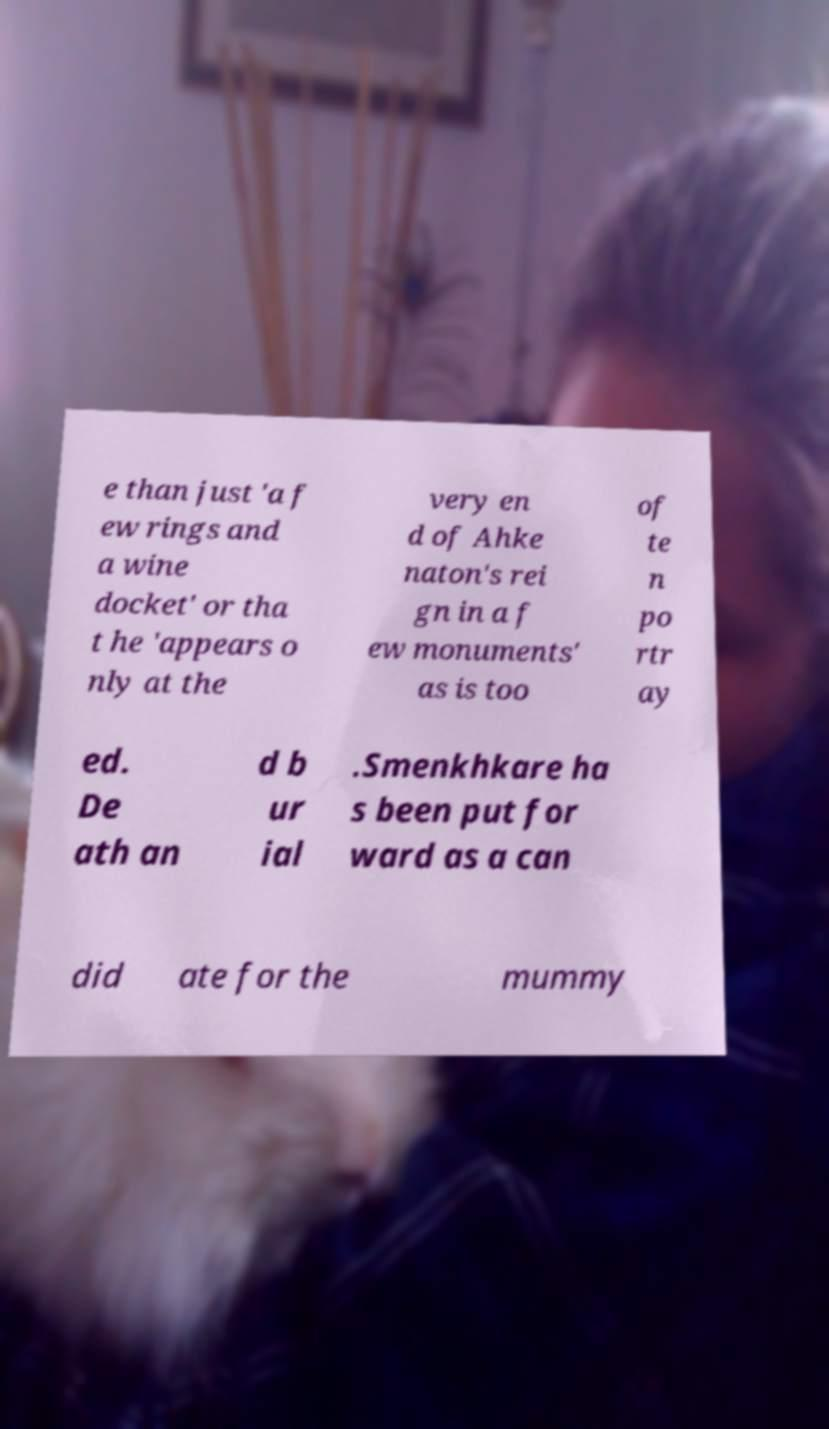For documentation purposes, I need the text within this image transcribed. Could you provide that? e than just 'a f ew rings and a wine docket' or tha t he 'appears o nly at the very en d of Ahke naton's rei gn in a f ew monuments' as is too of te n po rtr ay ed. De ath an d b ur ial .Smenkhkare ha s been put for ward as a can did ate for the mummy 